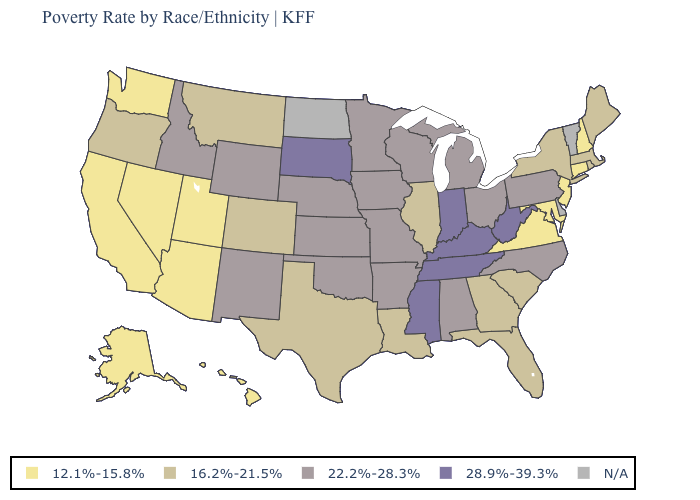Name the states that have a value in the range 28.9%-39.3%?
Keep it brief. Indiana, Kentucky, Mississippi, South Dakota, Tennessee, West Virginia. How many symbols are there in the legend?
Quick response, please. 5. Which states have the lowest value in the Northeast?
Concise answer only. Connecticut, New Hampshire, New Jersey. What is the value of Nebraska?
Answer briefly. 22.2%-28.3%. Does the first symbol in the legend represent the smallest category?
Quick response, please. Yes. Among the states that border North Dakota , which have the lowest value?
Be succinct. Montana. What is the value of Wyoming?
Keep it brief. 22.2%-28.3%. Does the first symbol in the legend represent the smallest category?
Keep it brief. Yes. Name the states that have a value in the range N/A?
Answer briefly. Delaware, North Dakota, Vermont. Does Pennsylvania have the highest value in the Northeast?
Answer briefly. Yes. Name the states that have a value in the range N/A?
Quick response, please. Delaware, North Dakota, Vermont. What is the value of Utah?
Give a very brief answer. 12.1%-15.8%. What is the lowest value in the South?
Be succinct. 12.1%-15.8%. What is the value of Arizona?
Answer briefly. 12.1%-15.8%. Which states hav the highest value in the MidWest?
Quick response, please. Indiana, South Dakota. 